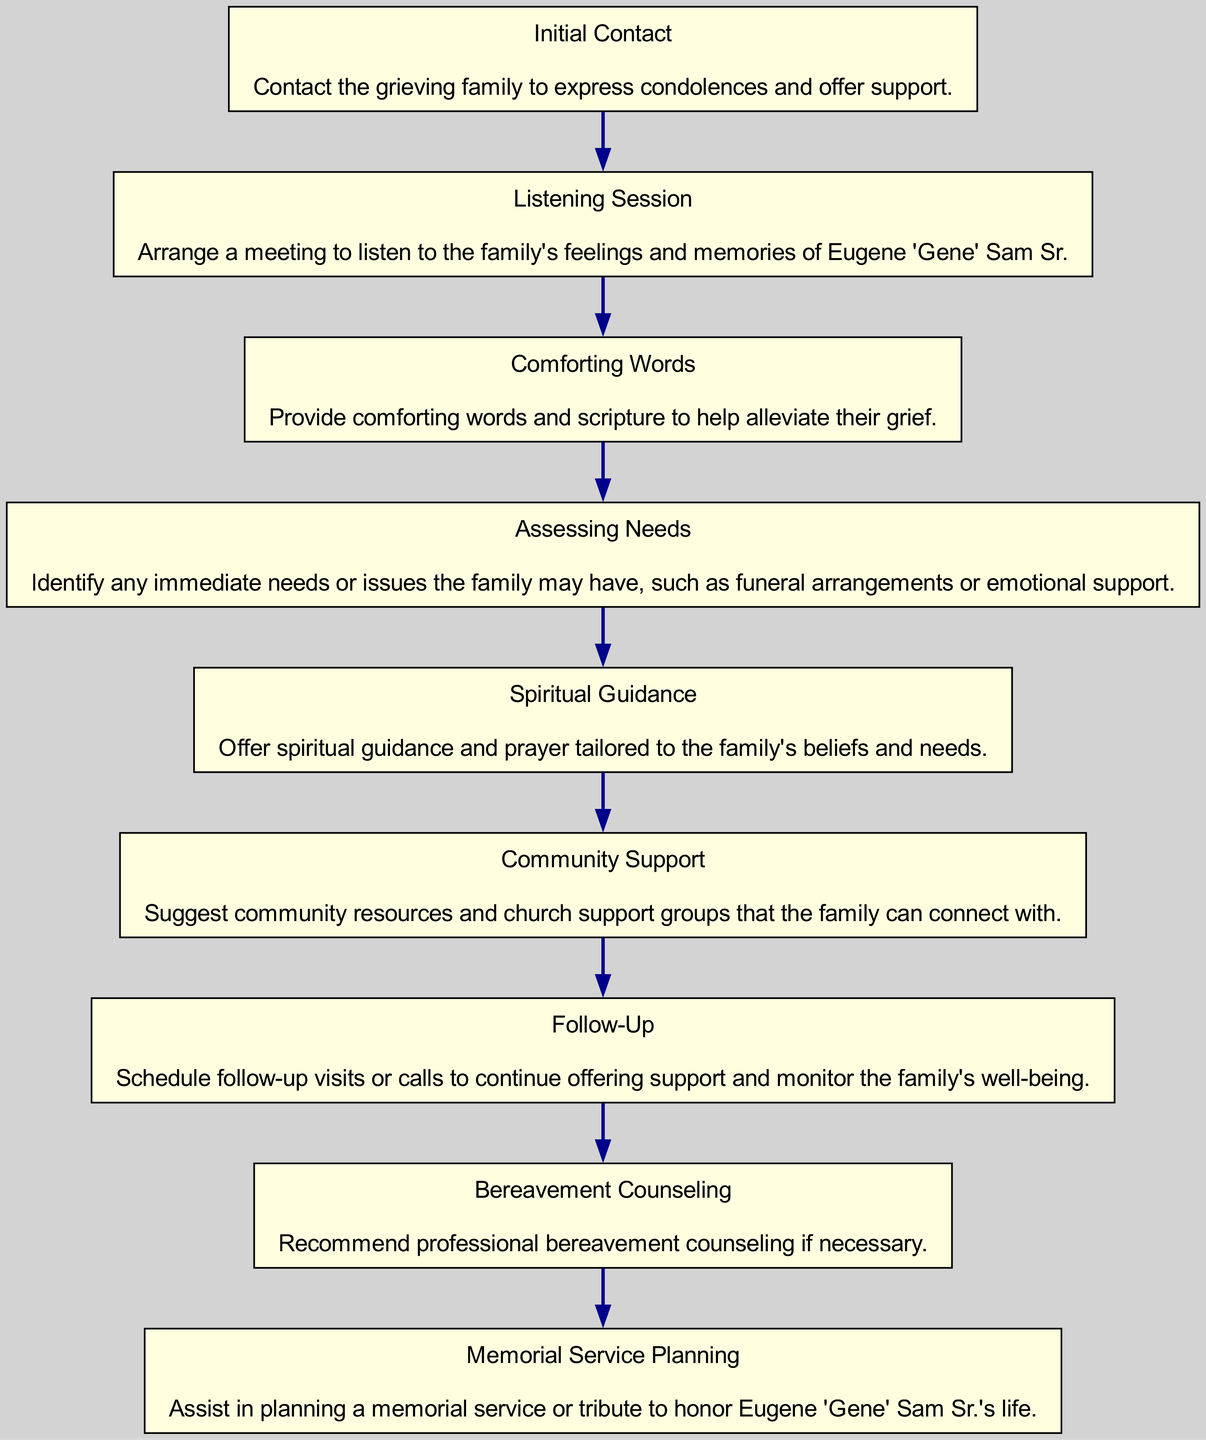What is the first step in counseling a grieving family? The first step is clearly stated as "Initial Contact," where the counselor reaches out to express condolences and offer support.
Answer: Initial Contact How many steps are there in total in the diagram? Counting through the elements listed, there are 9 steps in total shown in the diagram.
Answer: 9 What step follows "Assessing Needs"? The step that follows "Assessing Needs" is "Spiritual Guidance," indicating the flow of actions taken in the counseling process.
Answer: Spiritual Guidance What is the last step in the diagram? The last step listed in the flow chart is "Follow-Up," which emphasizes the importance of continued support after initial counseling.
Answer: Follow-Up What key action happens during "Listening Session"? During the "Listening Session," the key action is to arrange a meeting to listen to the family's feelings and memories of Eugene 'Gene' Sam Sr.
Answer: Listening to memories Which step suggests community resources? The step that suggests community resources is "Community Support," where the counselor connects the family with support groups.
Answer: Community Support What do you provide in the "Comforting Words" step? In this step, the counselor provides comforting words and scripture to help alleviate the family's grief, supporting them emotionally.
Answer: Comforting words and scripture Which step involves planning a tribute? The step where planning a tribute occurs is "Memorial Service Planning," aiding the family in honoring the deceased's life.
Answer: Memorial Service Planning If "Bereavement Counseling" is recommended, what does this imply? This implies the need for professional bereavement counseling if the family's grief is profound and requires expert support beyond initial counseling efforts.
Answer: Professional support needed 